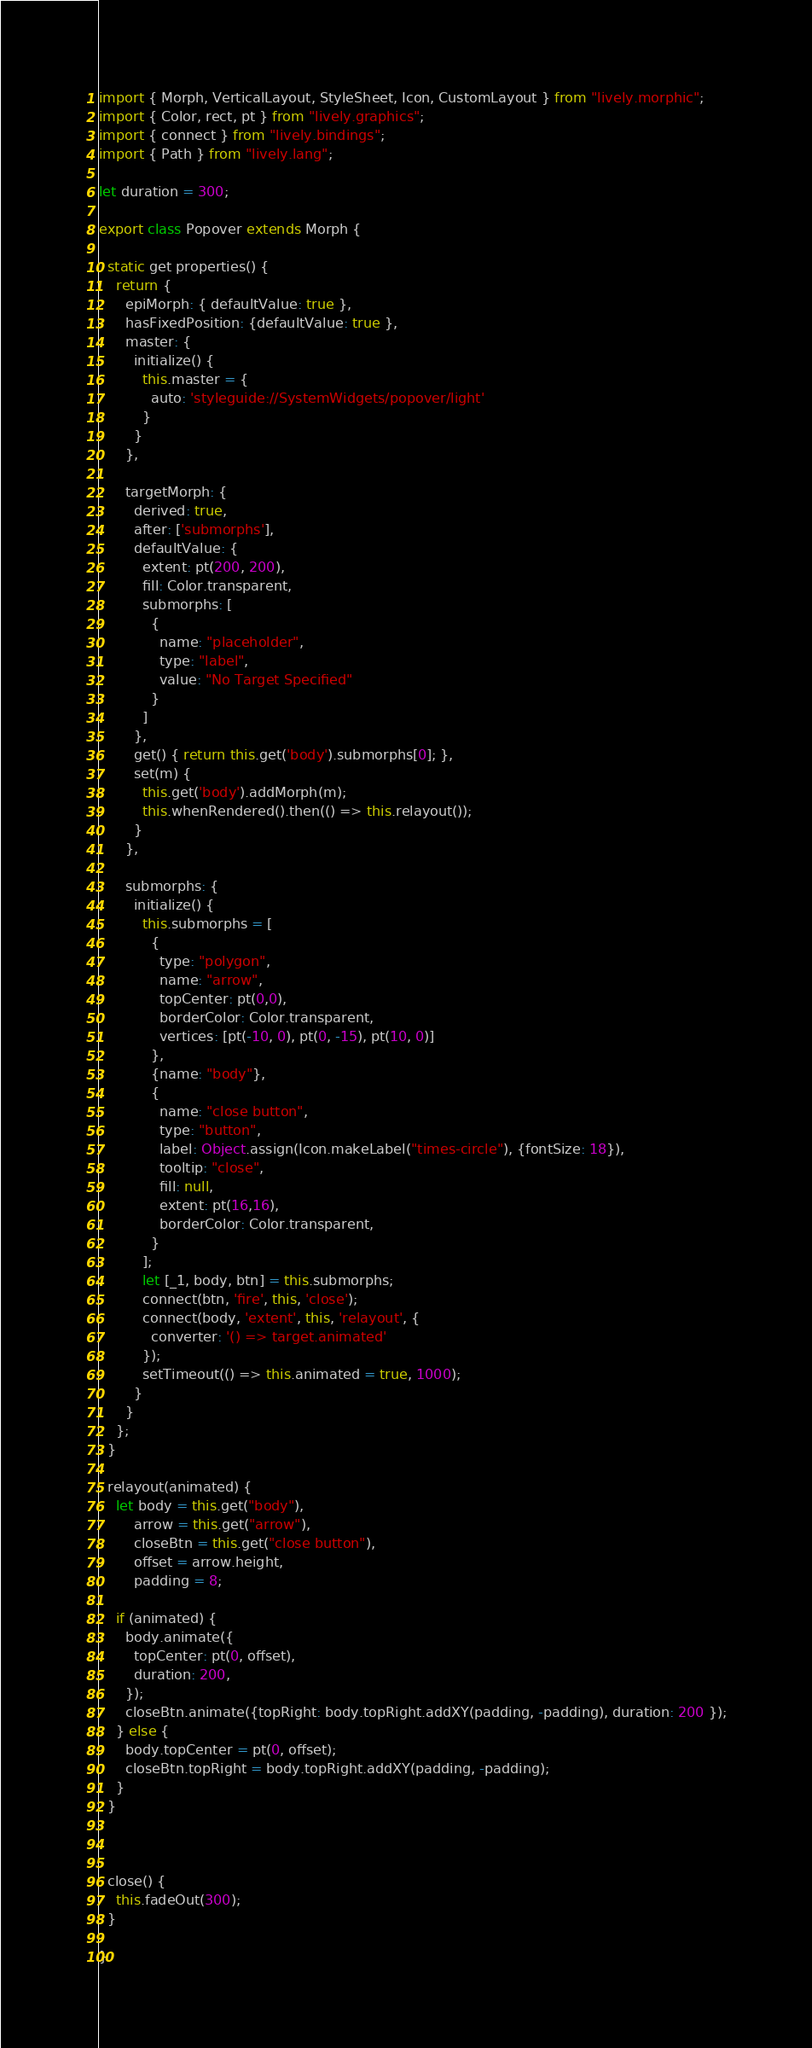Convert code to text. <code><loc_0><loc_0><loc_500><loc_500><_JavaScript_>import { Morph, VerticalLayout, StyleSheet, Icon, CustomLayout } from "lively.morphic";
import { Color, rect, pt } from "lively.graphics";
import { connect } from "lively.bindings";
import { Path } from "lively.lang";

let duration = 300;

export class Popover extends Morph {

  static get properties() {
    return {
      epiMorph: { defaultValue: true },
      hasFixedPosition: {defaultValue: true },
      master: {
        initialize() {
          this.master = {
            auto: 'styleguide://SystemWidgets/popover/light'
          }
        }
      },

      targetMorph: {
        derived: true,
        after: ['submorphs'],
        defaultValue: {
          extent: pt(200, 200),
          fill: Color.transparent,
          submorphs: [
            {
              name: "placeholder",
              type: "label",
              value: "No Target Specified"
            }
          ]
        },
        get() { return this.get('body').submorphs[0]; },
        set(m) {
          this.get('body').addMorph(m);
          this.whenRendered().then(() => this.relayout());
        }
      },

      submorphs: {
        initialize() {
          this.submorphs = [
            {
              type: "polygon",
              name: "arrow",
              topCenter: pt(0,0),
              borderColor: Color.transparent,
              vertices: [pt(-10, 0), pt(0, -15), pt(10, 0)]
            },
            {name: "body"},
            {
              name: "close button",
              type: "button",
              label: Object.assign(Icon.makeLabel("times-circle"), {fontSize: 18}),
              tooltip: "close",
              fill: null,
              extent: pt(16,16),
              borderColor: Color.transparent,
            }
          ];
          let [_1, body, btn] = this.submorphs;
          connect(btn, 'fire', this, 'close');
          connect(body, 'extent', this, 'relayout', {
            converter: '() => target.animated'
          });
          setTimeout(() => this.animated = true, 1000);
        }
      }
    };
  }

  relayout(animated) {
    let body = this.get("body"),
        arrow = this.get("arrow"),
        closeBtn = this.get("close button"),
        offset = arrow.height,
        padding = 8;

    if (animated) {
      body.animate({
        topCenter: pt(0, offset),
        duration: 200,
      });
      closeBtn.animate({topRight: body.topRight.addXY(padding, -padding), duration: 200 });
    } else {
      body.topCenter = pt(0, offset);
      closeBtn.topRight = body.topRight.addXY(padding, -padding);
    }
  }

  

  close() {
    this.fadeOut(300);
  }

}</code> 